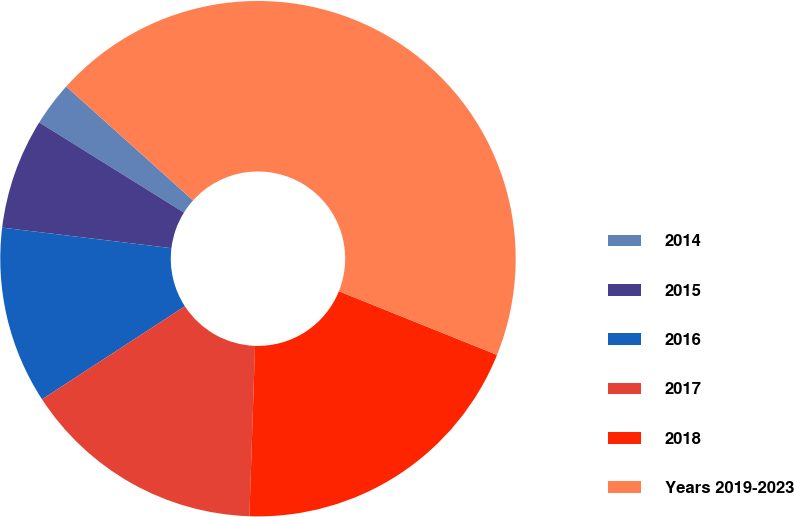<chart> <loc_0><loc_0><loc_500><loc_500><pie_chart><fcel>2014<fcel>2015<fcel>2016<fcel>2017<fcel>2018<fcel>Years 2019-2023<nl><fcel>2.78%<fcel>6.94%<fcel>11.11%<fcel>15.28%<fcel>19.44%<fcel>44.44%<nl></chart> 